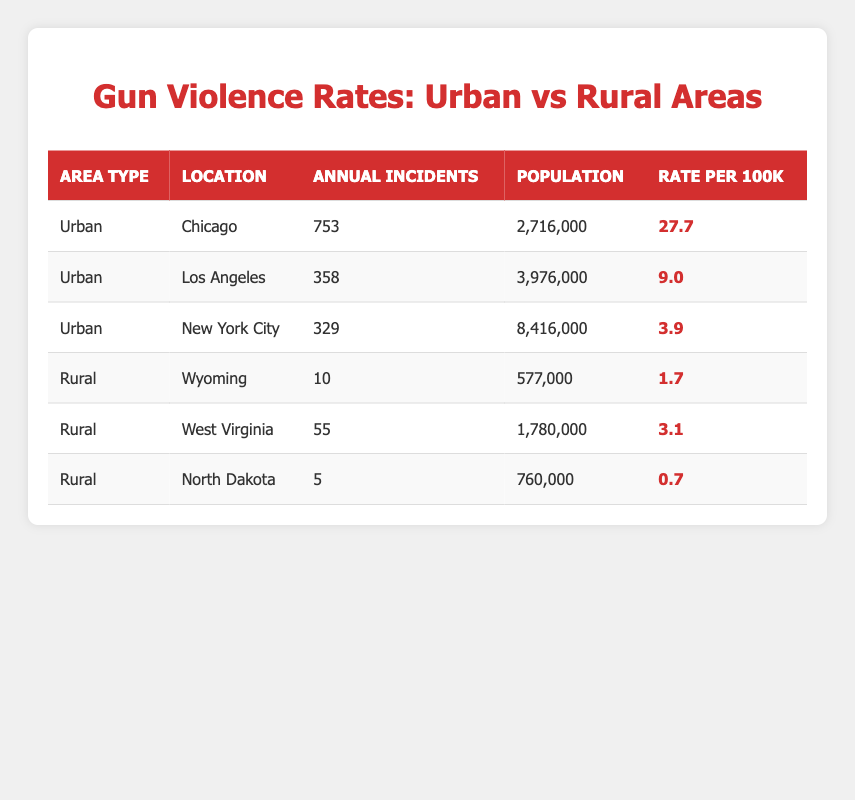What is the gun violence rate per 100,000 people in Chicago? According to the table, the rate per 100,000 people in Chicago is shown as 27.7. Therefore, this value is directly retrieved from the urban area row for Chicago.
Answer: 27.7 Which rural area has the highest annual incidents of gun violence? Examining the annual incidents in rural areas, West Virginia has 55 incidents. Wyoming has 10 incidents and North Dakota has 5. Thus, West Virginia is the rural area with the highest number of incidents.
Answer: West Virginia What is the total number of annual gun violence incidents reported in urban areas? By adding the annual incidents in urban areas from the table: 753 (Chicago) + 358 (Los Angeles) + 329 (New York City) = 1440. Therefore, the total number of incidents is 1440.
Answer: 1440 Is the gun violence rate in Wyoming higher than that of New York City? The table shows that the rate in Wyoming is 1.7, whereas New York City has a rate of 3.9. Since 1.7 is less than 3.9, this statement is false.
Answer: No What is the average gun violence rate per 100,000 people for the three urban areas listed? To find the average, sum the rates: 27.7 (Chicago) + 9.0 (Los Angeles) + 3.9 (New York City) = 40.6, then divide by 3 (the number of urban areas): 40.6 / 3 = 13.53. Thus, the average rate is approximately 13.53.
Answer: 13.53 Which area type (urban or rural) has a lower average gun violence rate and what is that rate? First, calculate the average for urban areas: (27.7 + 9.0 + 3.9) / 3 = 13.53. Now for rural areas: (1.7 + 3.1 + 0.7) / 3 = 1.5. Since 1.5 is less than 13.53, rural areas have a lower average gun violence rate.
Answer: Rural areas, 1.5 How many total residents are covered in all three urban cities combined? Sum the populations of the urban areas: 2,716,000 (Chicago) + 3,976,000 (Los Angeles) + 8,416,000 (New York City) = 15,108,000. Therefore, the total number of residents is 15,108,000.
Answer: 15,108,000 